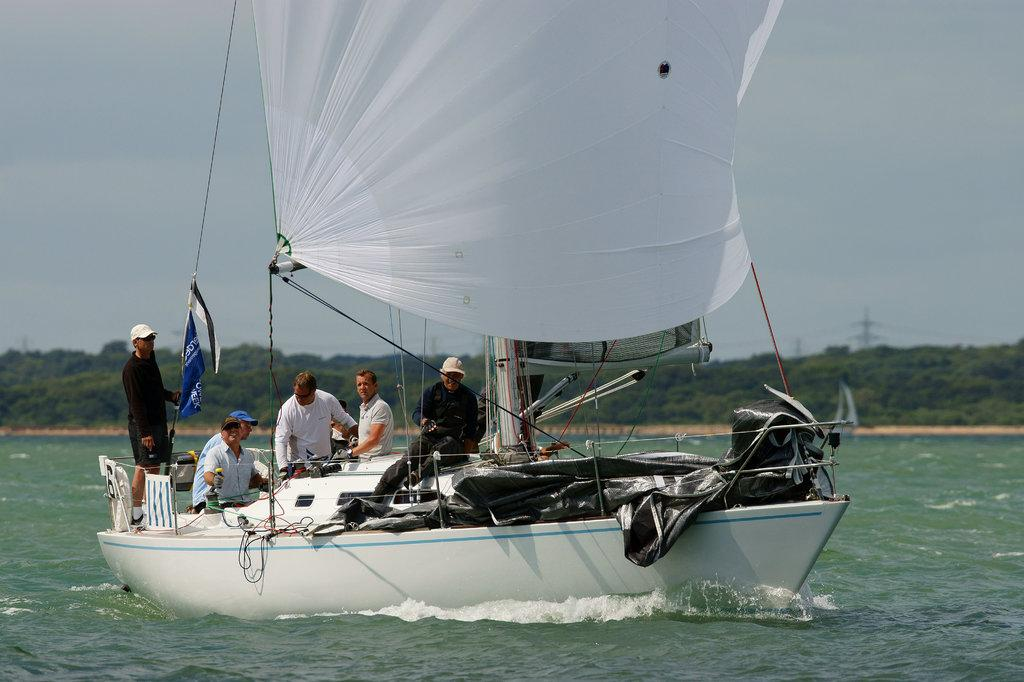What is the main subject of the image? The main subject of the image is a ship. Where is the ship located? The ship is on the water. Are there any people on the ship? Yes, there are people on the ship. What can be seen on the ship besides the people? There are ropes, a black cover, and other objects on the ship. What is visible in the background of the image? Trees can be seen in the background of the image. How would you describe the sky in the image? The sky is blue and white in color. What type of furniture can be seen on the ship in the image? There is no furniture visible on the ship in the image. Is there a cannon on the ship in the image? There is no cannon present on the ship in the image. 